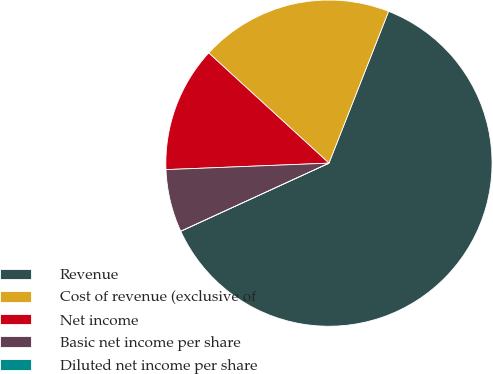Convert chart to OTSL. <chart><loc_0><loc_0><loc_500><loc_500><pie_chart><fcel>Revenue<fcel>Cost of revenue (exclusive of<fcel>Net income<fcel>Basic net income per share<fcel>Diluted net income per share<nl><fcel>62.19%<fcel>19.15%<fcel>12.44%<fcel>6.22%<fcel>0.0%<nl></chart> 